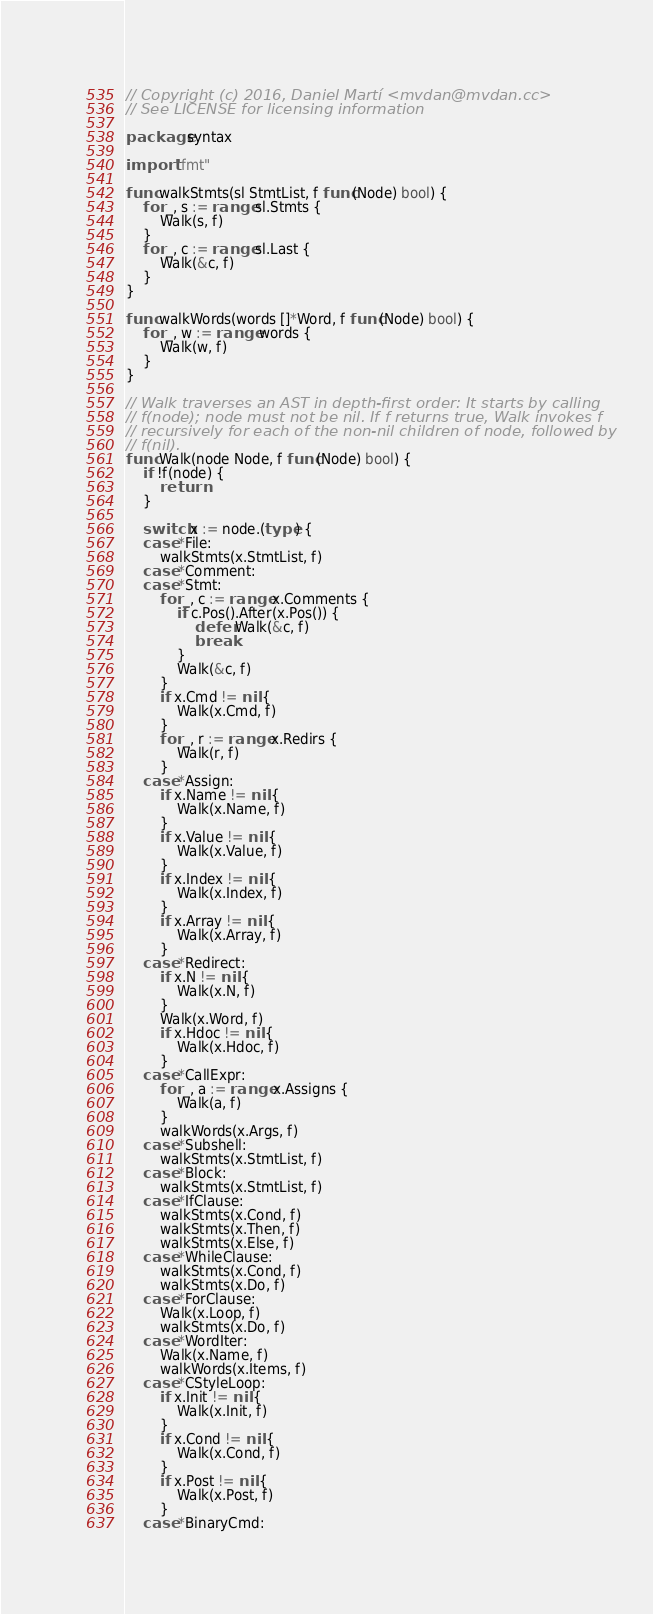Convert code to text. <code><loc_0><loc_0><loc_500><loc_500><_Go_>// Copyright (c) 2016, Daniel Martí <mvdan@mvdan.cc>
// See LICENSE for licensing information

package syntax

import "fmt"

func walkStmts(sl StmtList, f func(Node) bool) {
	for _, s := range sl.Stmts {
		Walk(s, f)
	}
	for _, c := range sl.Last {
		Walk(&c, f)
	}
}

func walkWords(words []*Word, f func(Node) bool) {
	for _, w := range words {
		Walk(w, f)
	}
}

// Walk traverses an AST in depth-first order: It starts by calling
// f(node); node must not be nil. If f returns true, Walk invokes f
// recursively for each of the non-nil children of node, followed by
// f(nil).
func Walk(node Node, f func(Node) bool) {
	if !f(node) {
		return
	}

	switch x := node.(type) {
	case *File:
		walkStmts(x.StmtList, f)
	case *Comment:
	case *Stmt:
		for _, c := range x.Comments {
			if c.Pos().After(x.Pos()) {
				defer Walk(&c, f)
				break
			}
			Walk(&c, f)
		}
		if x.Cmd != nil {
			Walk(x.Cmd, f)
		}
		for _, r := range x.Redirs {
			Walk(r, f)
		}
	case *Assign:
		if x.Name != nil {
			Walk(x.Name, f)
		}
		if x.Value != nil {
			Walk(x.Value, f)
		}
		if x.Index != nil {
			Walk(x.Index, f)
		}
		if x.Array != nil {
			Walk(x.Array, f)
		}
	case *Redirect:
		if x.N != nil {
			Walk(x.N, f)
		}
		Walk(x.Word, f)
		if x.Hdoc != nil {
			Walk(x.Hdoc, f)
		}
	case *CallExpr:
		for _, a := range x.Assigns {
			Walk(a, f)
		}
		walkWords(x.Args, f)
	case *Subshell:
		walkStmts(x.StmtList, f)
	case *Block:
		walkStmts(x.StmtList, f)
	case *IfClause:
		walkStmts(x.Cond, f)
		walkStmts(x.Then, f)
		walkStmts(x.Else, f)
	case *WhileClause:
		walkStmts(x.Cond, f)
		walkStmts(x.Do, f)
	case *ForClause:
		Walk(x.Loop, f)
		walkStmts(x.Do, f)
	case *WordIter:
		Walk(x.Name, f)
		walkWords(x.Items, f)
	case *CStyleLoop:
		if x.Init != nil {
			Walk(x.Init, f)
		}
		if x.Cond != nil {
			Walk(x.Cond, f)
		}
		if x.Post != nil {
			Walk(x.Post, f)
		}
	case *BinaryCmd:</code> 